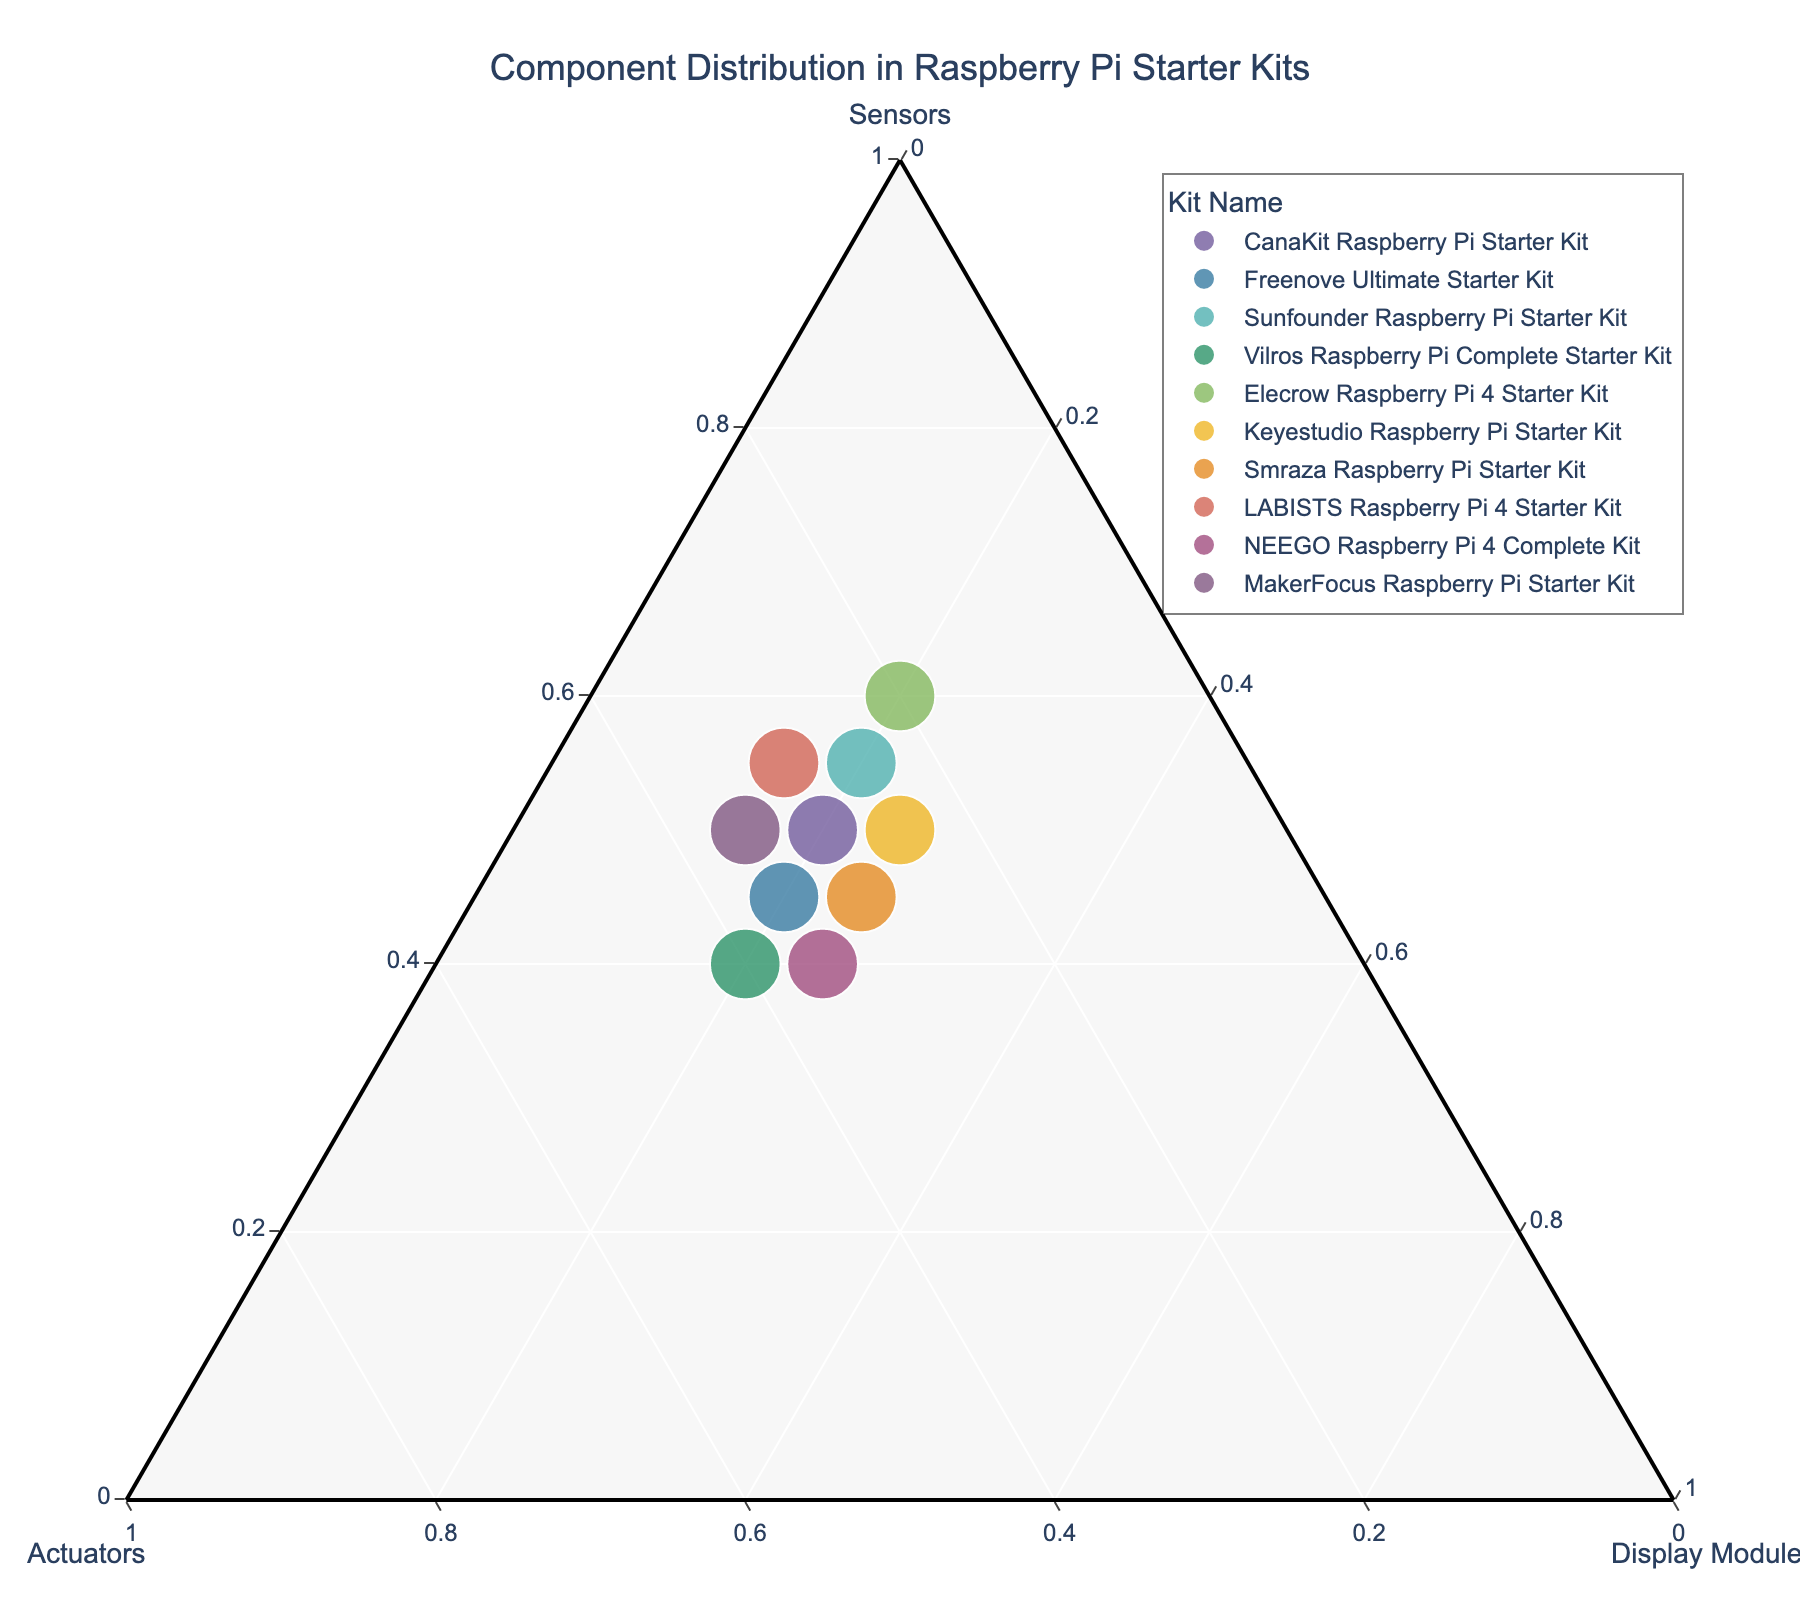What are the three components distributed in the kits? The title of the plot indicates "Component Distribution in Raspberry Pi Starter Kits", and the axes labels indicate "Sensors", "Actuators", and "Display Modules".
Answer: Sensors, Actuators, Display Modules Which kit has the highest proportion of sensors? Looking for the data point closest to the "Sensors" corner of the ternary plot reveals the "Elecrow Raspberry Pi 4 Starter Kit" as it has the highest Sensors proportion.
Answer: Elecrow Raspberry Pi 4 Starter Kit Which kits have an equal proportion of display modules? Checking the axis labels and the kit positions show that both the "Keyestudio Raspberry Pi Starter Kit" and the "Smraza Raspberry Pi Starter Kit" share equal proportions of display modules, along with several others aligned along the same vertical axis for Display Modules.
Answer: Keyestudio Raspberry Pi Starter Kit, Smraza Raspberry Pi Starter Kit Which kit has the highest total number of components? By looking at the size of the points, the larger the point, the higher the total number of components. The "Sunfounder Raspberry Pi Starter Kit" has one of the largest points. Check the hover information for confirmation.
Answer: Sunfounder Raspberry Pi Starter Kit What's the proportion of actuators in the CanaKit Raspberry Pi Starter Kit? Locate the CanaKit Raspberry Pi Starter Kit on the ternary plot and check the position relative to the "Actuators" axis. The kit is distributed at 30% actuators as per hover data.
Answer: 30% Compare the proportion of sensors between the Freenove and NEEGO starter kits. Which has more? Hover over the two kits' points on the plot and observe the proportion values. Freenove has 45% sensors whereas NEEGO has 40%.
Answer: Freenove has more Is there any kit with an equal distribution of sensors, actuators, and display modules? Check for data points located around the center of the ternary plot where equal distribution would map. None of the given kits shows an equal distribution of 33.3% each.
Answer: No Calculate the average proportion of display modules in all starter kits. Sum the proportions of display modules for all kits (10 kits) which total to 200%, then divide by the number of kits: 200% / 10 kits.
Answer: 20% Which kit has the smallest proportion of display modules? Locate the point closest to the "Display Modules" axis's origin. The "LABISTS Raspberry Pi 4 Starter Kit" has the lowest proportion of display modules at 15%.
Answer: LABISTS Raspberry Pi 4 Starter Kit 